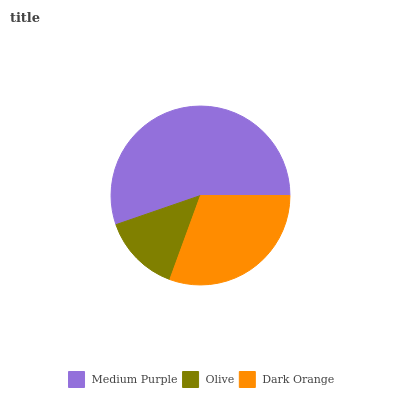Is Olive the minimum?
Answer yes or no. Yes. Is Medium Purple the maximum?
Answer yes or no. Yes. Is Dark Orange the minimum?
Answer yes or no. No. Is Dark Orange the maximum?
Answer yes or no. No. Is Dark Orange greater than Olive?
Answer yes or no. Yes. Is Olive less than Dark Orange?
Answer yes or no. Yes. Is Olive greater than Dark Orange?
Answer yes or no. No. Is Dark Orange less than Olive?
Answer yes or no. No. Is Dark Orange the high median?
Answer yes or no. Yes. Is Dark Orange the low median?
Answer yes or no. Yes. Is Medium Purple the high median?
Answer yes or no. No. Is Medium Purple the low median?
Answer yes or no. No. 